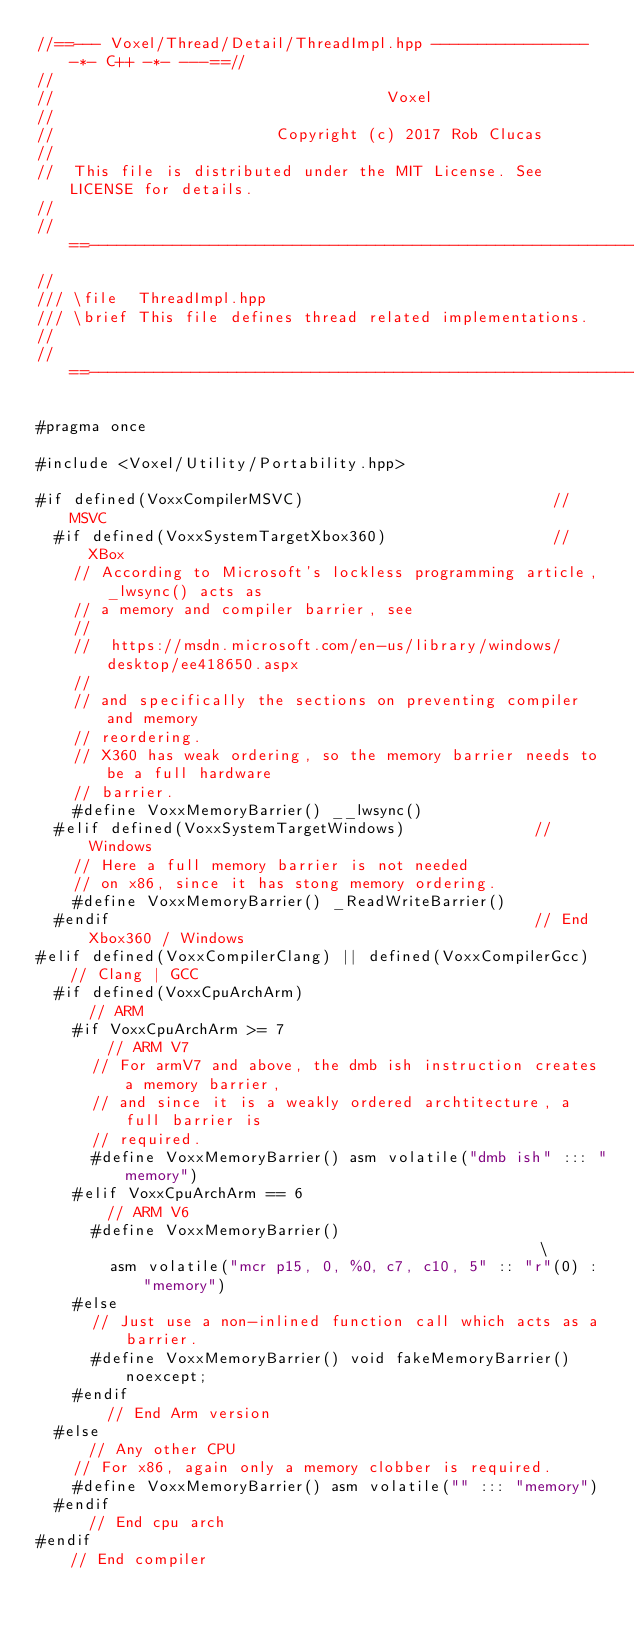Convert code to text. <code><loc_0><loc_0><loc_500><loc_500><_C++_>//==--- Voxel/Thread/Detail/ThreadImpl.hpp ----------------- -*- C++ -*- ---==//
//            
//                                    Voxel
//
//                        Copyright (c) 2017 Rob Clucas
//  
//  This file is distributed under the MIT License. See LICENSE for details.
//  
//==------------------------------------------------------------------------==//
//
/// \file  ThreadImpl.hpp
/// \brief This file defines thread related implementations.
// 
//==------------------------------------------------------------------------==//

#pragma once

#include <Voxel/Utility/Portability.hpp>

#if defined(VoxxCompilerMSVC)                           // MSVC
  #if defined(VoxxSystemTargetXbox360)                  // XBox
    // According to Microsoft's lockless programming article, _lwsync() acts as
    // a memory and compiler barrier, see 
    // 
    //  https://msdn.microsoft.com/en-us/library/windows/desktop/ee418650.aspx
    //  
    // and specifically the sections on preventing compiler and memory
    // reordering.
    // X360 has weak ordering, so the memory barrier needs to be a full hardware
    // barrier.
    #define VoxxMemoryBarrier() __lwsync()
  #elif defined(VoxxSystemTargetWindows)              // Windows
    // Here a full memory barrier is not needed
    // on x86, since it has stong memory ordering.
    #define VoxxMemoryBarrier() _ReadWriteBarrier()
  #endif                                              // End Xbox360 / Windows
#elif defined(VoxxCompilerClang) || defined(VoxxCompilerGcc)  // Clang | GCC
  #if defined(VoxxCpuArchArm)                                 // ARM
    #if VoxxCpuArchArm >= 7                                   // ARM V7
      // For armV7 and above, the dmb ish instruction creates a memory barrier,
      // and since it is a weakly ordered archtitecture, a full barrier is
      // required.
      #define VoxxMemoryBarrier() asm volatile("dmb ish" ::: "memory")
    #elif VoxxCpuArchArm == 6                                 // ARM V6
      #define VoxxMemoryBarrier()                                              \
        asm volatile("mcr p15, 0, %0, c7, c10, 5" :: "r"(0) : "memory")
    #else
      // Just use a non-inlined function call which acts as a barrier.
      #define VoxxMemoryBarrier() void fakeMemoryBarrier() noexcept;
    #endif                                                    // End Arm version
  #else                                                       // Any other CPU
    // For x86, again only a memory clobber is required.
    #define VoxxMemoryBarrier() asm volatile("" ::: "memory")
  #endif                                                      // End cpu arch 
#endif                                                        // End compiler </code> 